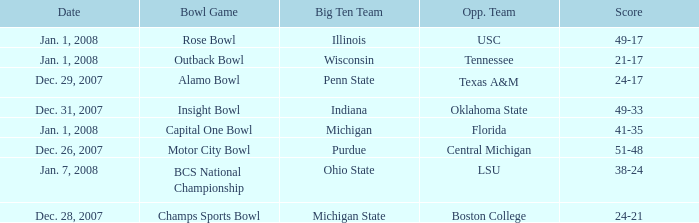What bowl game was played on Dec. 26, 2007? Motor City Bowl. Could you help me parse every detail presented in this table? {'header': ['Date', 'Bowl Game', 'Big Ten Team', 'Opp. Team', 'Score'], 'rows': [['Jan. 1, 2008', 'Rose Bowl', 'Illinois', 'USC', '49-17'], ['Jan. 1, 2008', 'Outback Bowl', 'Wisconsin', 'Tennessee', '21-17'], ['Dec. 29, 2007', 'Alamo Bowl', 'Penn State', 'Texas A&M', '24-17'], ['Dec. 31, 2007', 'Insight Bowl', 'Indiana', 'Oklahoma State', '49-33'], ['Jan. 1, 2008', 'Capital One Bowl', 'Michigan', 'Florida', '41-35'], ['Dec. 26, 2007', 'Motor City Bowl', 'Purdue', 'Central Michigan', '51-48'], ['Jan. 7, 2008', 'BCS National Championship', 'Ohio State', 'LSU', '38-24'], ['Dec. 28, 2007', 'Champs Sports Bowl', 'Michigan State', 'Boston College', '24-21']]} 